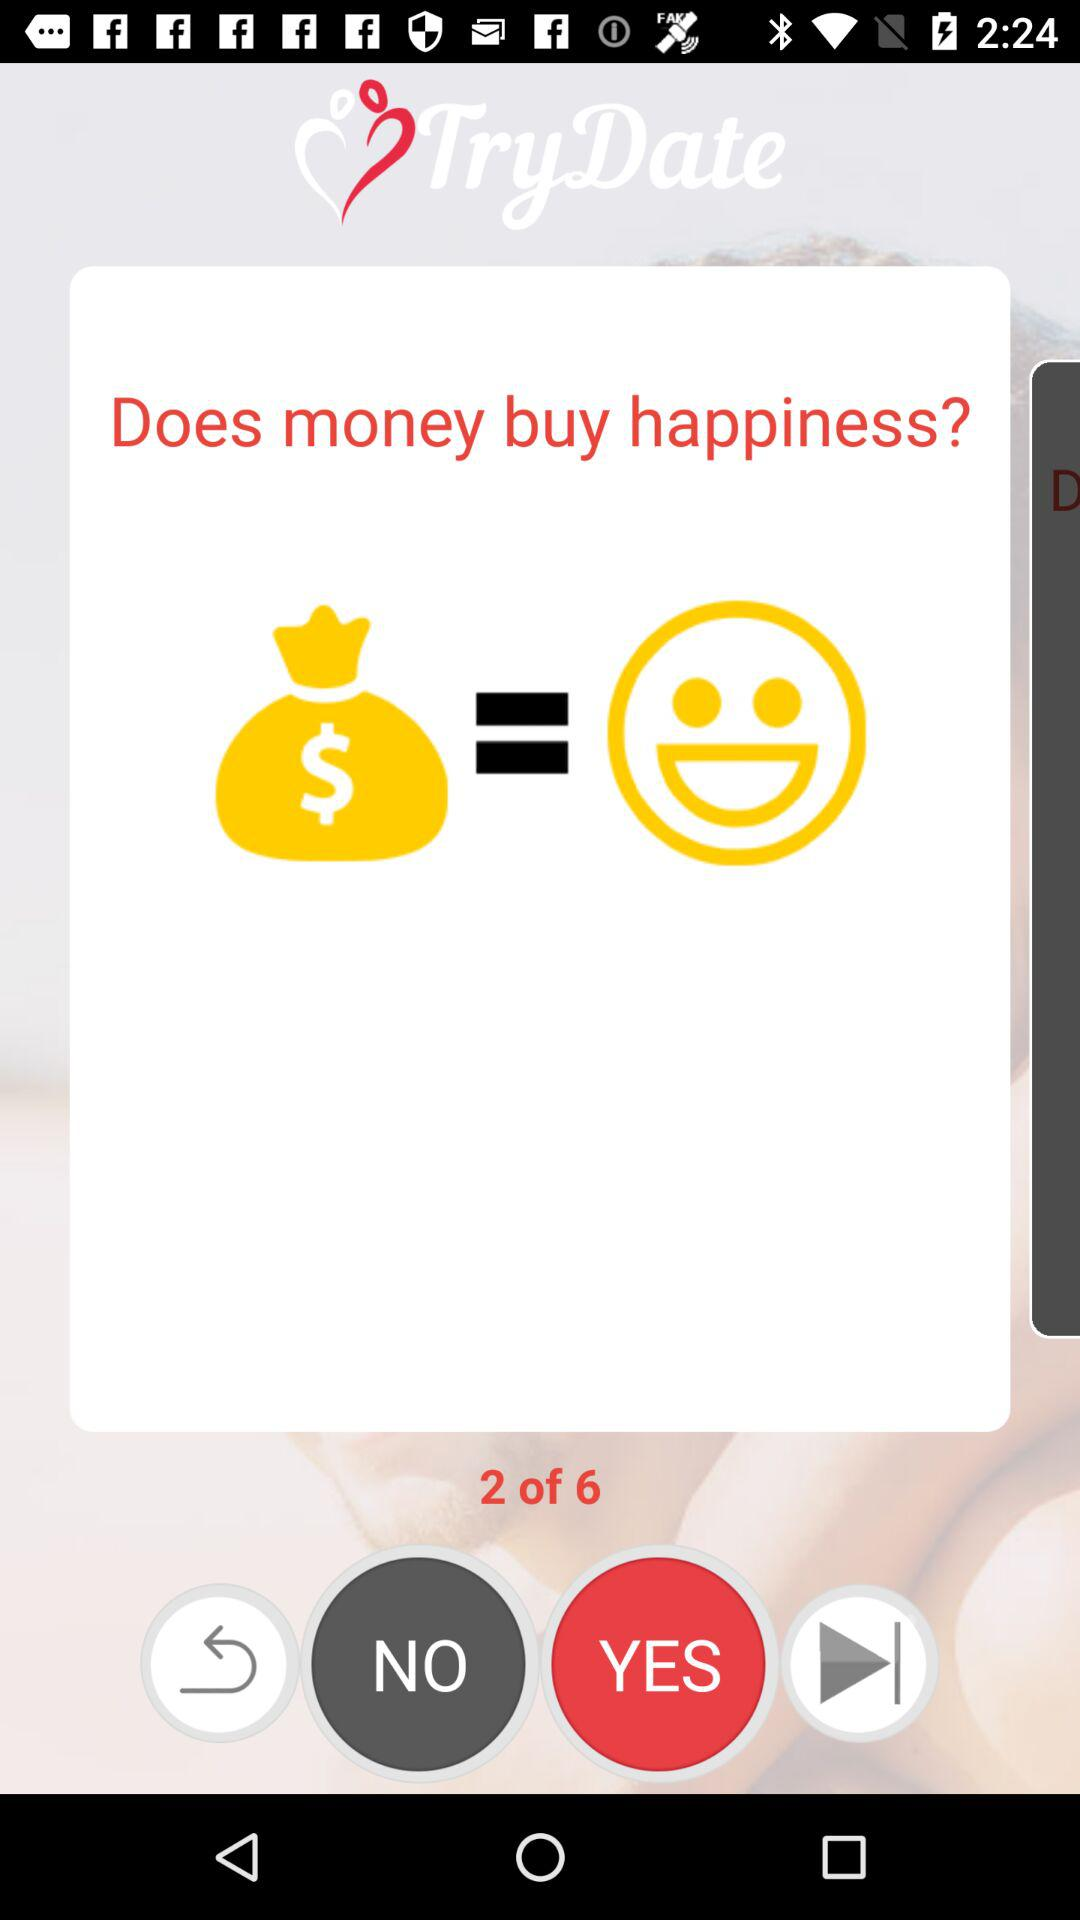How many questions in total are there? There are 6 questions. 